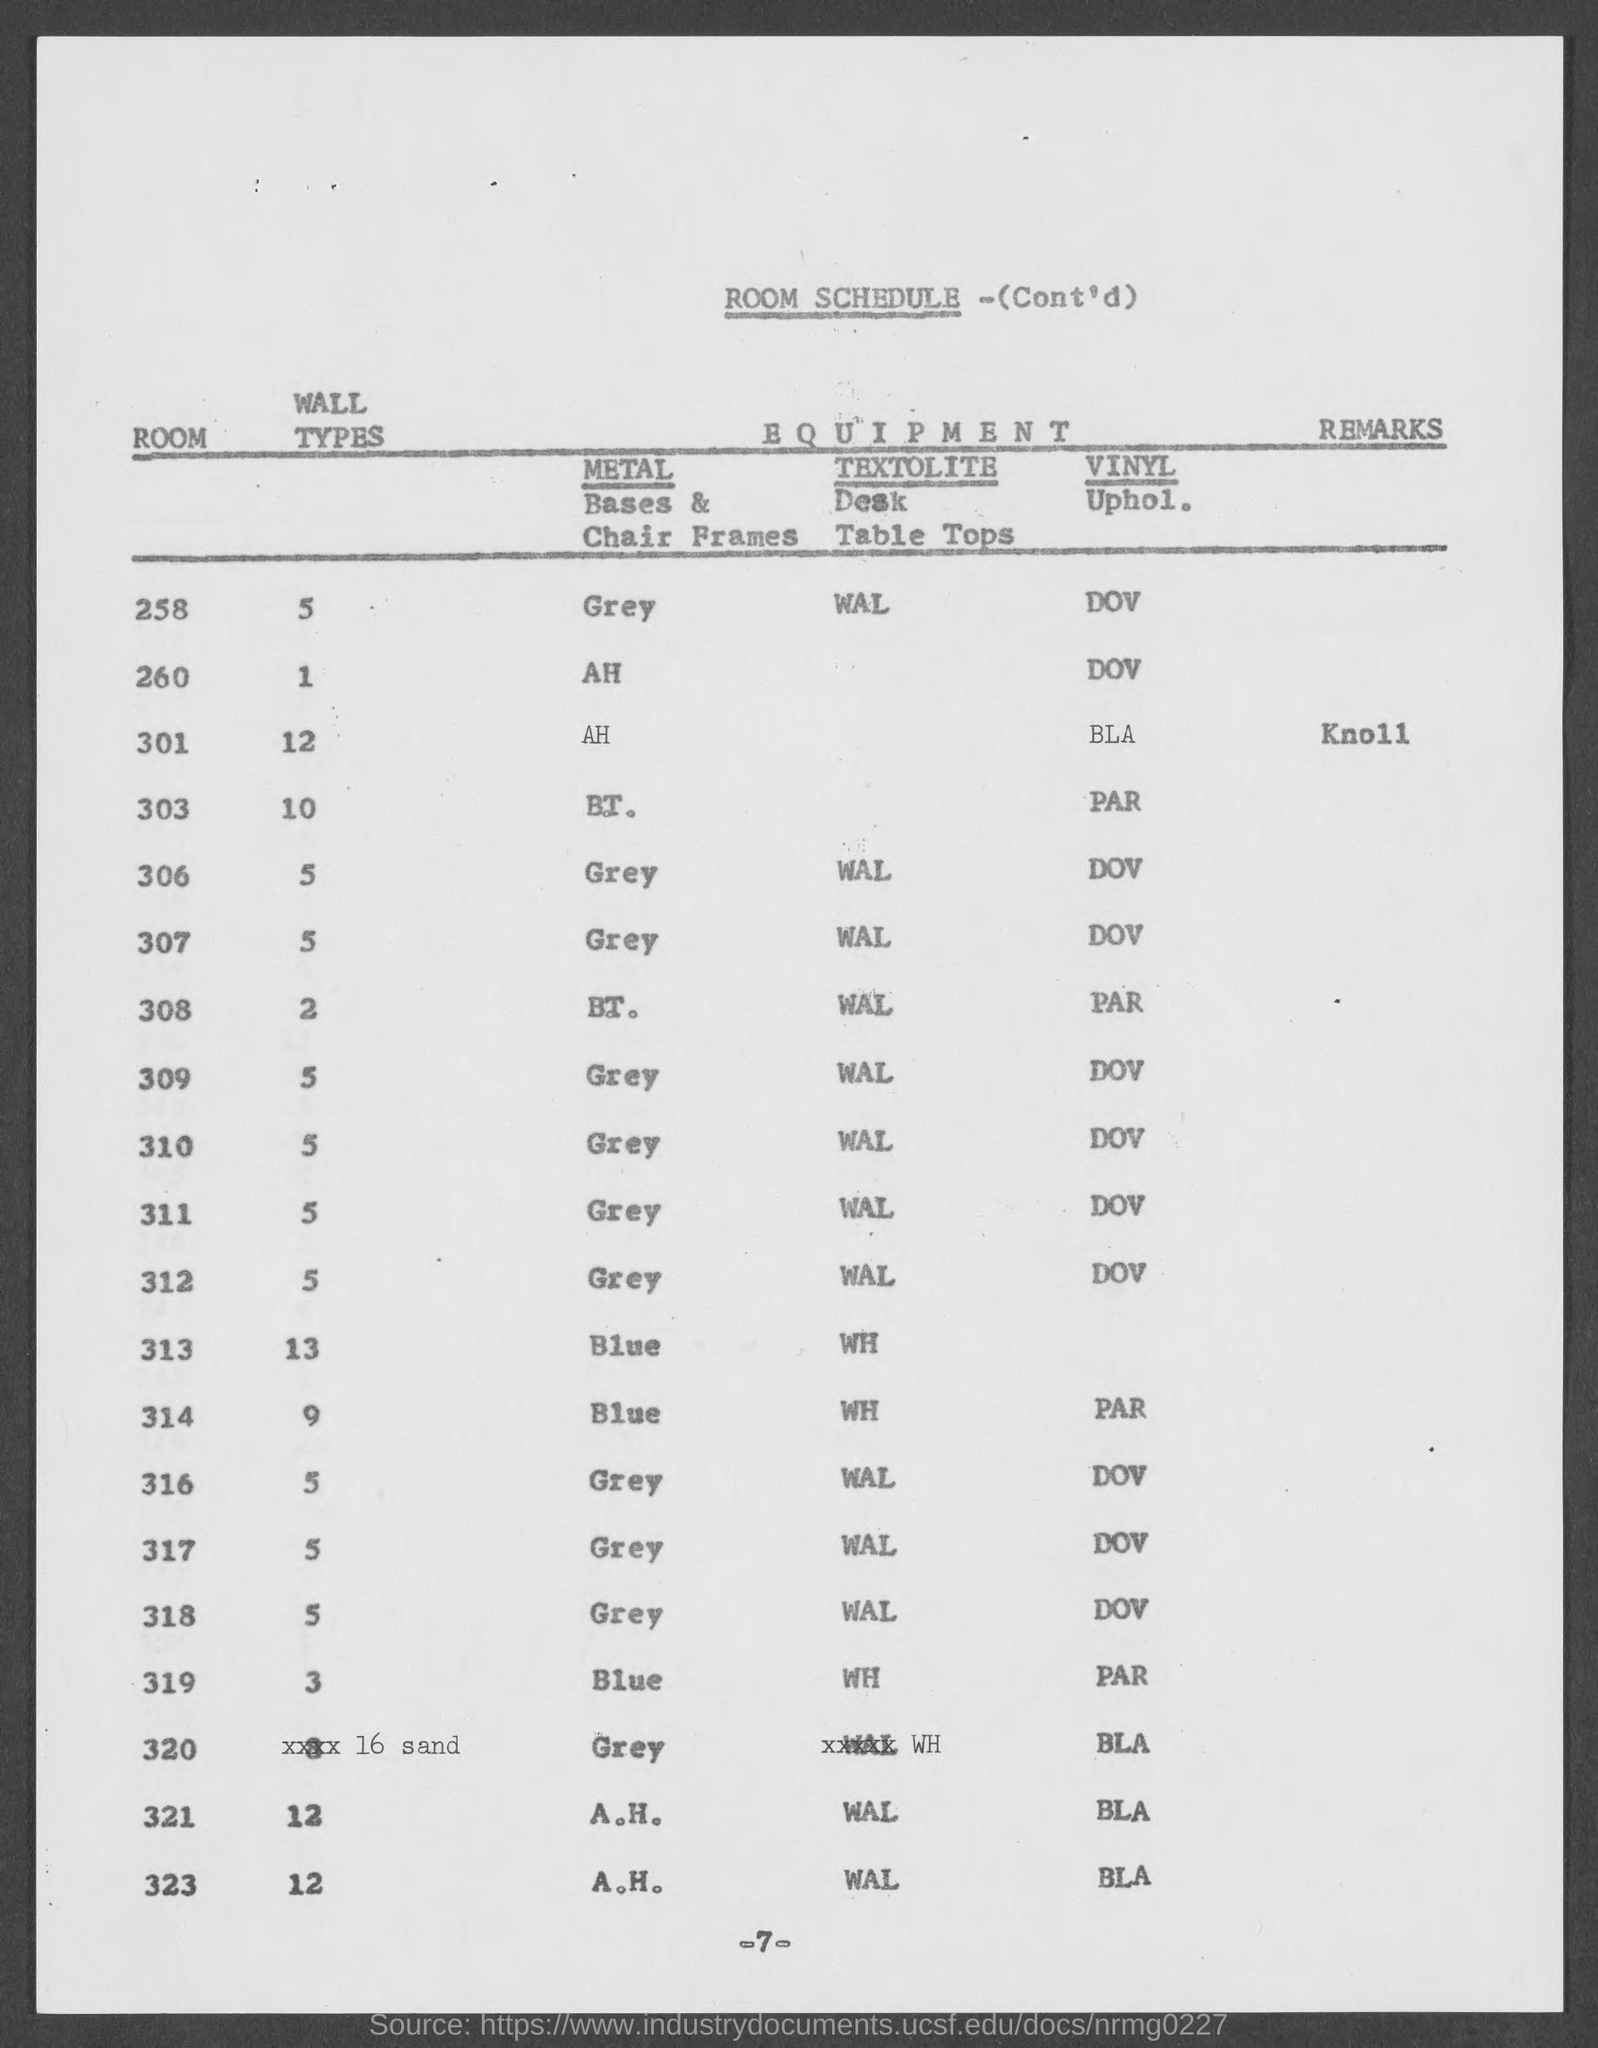What is the page number?
Give a very brief answer. 7. In Room 308 what are the Wall Types?
Provide a short and direct response. 2. 